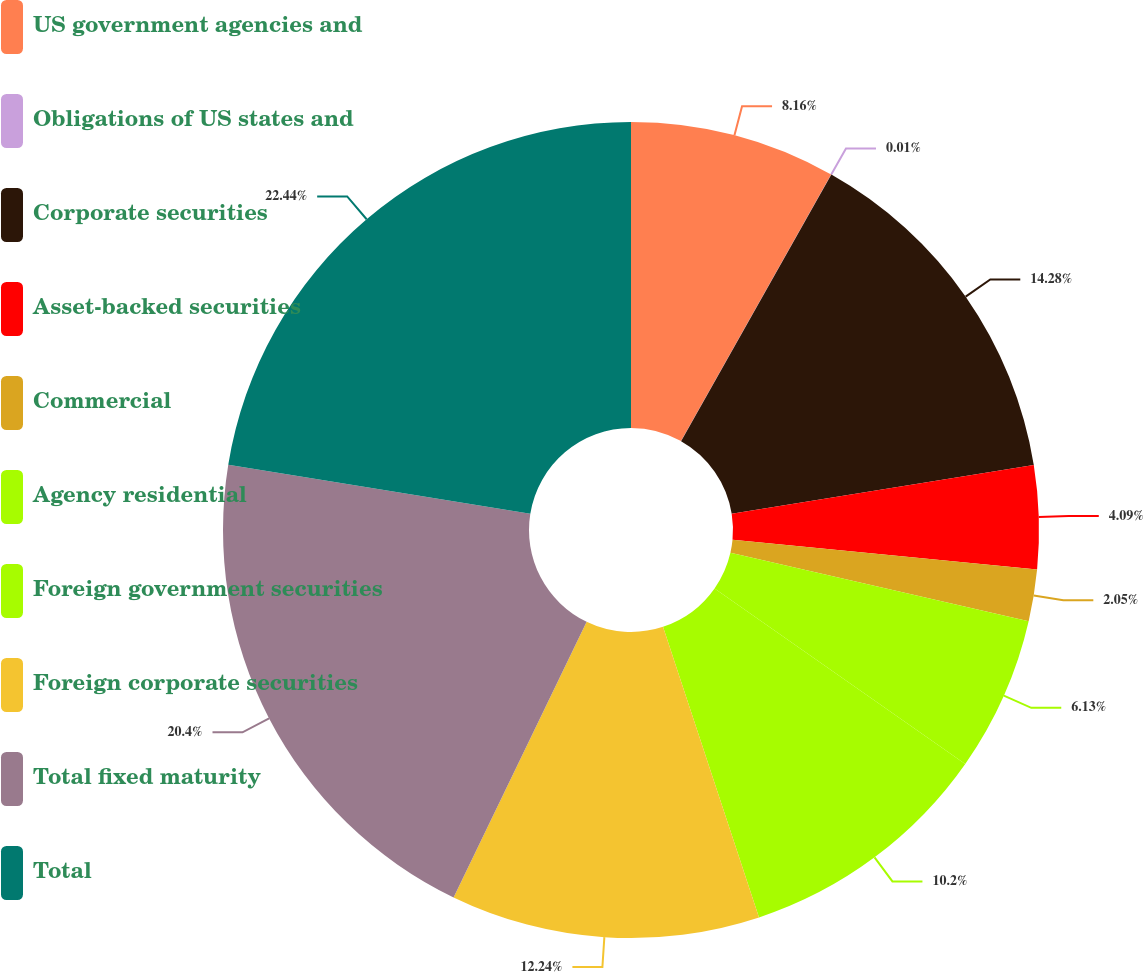Convert chart to OTSL. <chart><loc_0><loc_0><loc_500><loc_500><pie_chart><fcel>US government agencies and<fcel>Obligations of US states and<fcel>Corporate securities<fcel>Asset-backed securities<fcel>Commercial<fcel>Agency residential<fcel>Foreign government securities<fcel>Foreign corporate securities<fcel>Total fixed maturity<fcel>Total<nl><fcel>8.16%<fcel>0.01%<fcel>14.28%<fcel>4.09%<fcel>2.05%<fcel>6.13%<fcel>10.2%<fcel>12.24%<fcel>20.4%<fcel>22.44%<nl></chart> 